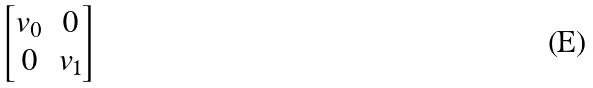<formula> <loc_0><loc_0><loc_500><loc_500>\begin{bmatrix} v _ { 0 } & 0 \\ 0 & v _ { 1 } \end{bmatrix}</formula> 